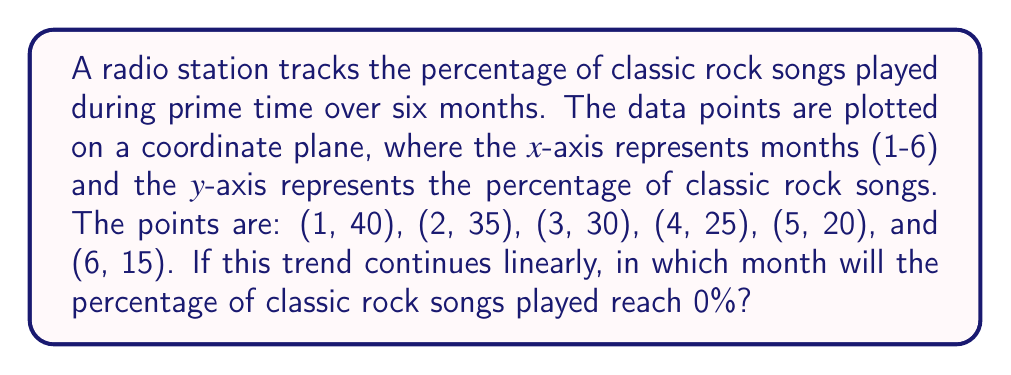Help me with this question. To solve this problem, we need to follow these steps:

1. Plot the given points on a coordinate plane.
2. Determine the slope of the line connecting these points.
3. Use the slope to find the equation of the line.
4. Solve the equation for y = 0 to find the x-value (month) when classic rock songs reach 0%.

Step 1: Plotting the points
We can visualize the points on a coordinate plane:

[asy]
size(200,200);
import graph;

xaxis("Months",0,8,Arrow);
yaxis("Percentage",0,50,Arrow);

for(int i=1; i<=6; ++i) {
  dot((i, 40-5*(i-1)));
}

draw((1,40)--(6,15),blue);
[/asy]

Step 2: Determining the slope
We can calculate the slope using any two points. Let's use (1, 40) and (6, 15):

$m = \frac{y_2 - y_1}{x_2 - x_1} = \frac{15 - 40}{6 - 1} = \frac{-25}{5} = -5$

The slope is -5, meaning the percentage decreases by 5% each month.

Step 3: Finding the equation of the line
Using the point-slope form of a line $(y - y_1 = m(x - x_1))$ and the point (1, 40):

$y - 40 = -5(x - 1)$
$y - 40 = -5x + 5$
$y = -5x + 45$

Step 4: Solving for y = 0
To find when the percentage reaches 0%, we set y to 0 and solve for x:

$0 = -5x + 45$
$5x = 45$
$x = 9$

Therefore, if the trend continues linearly, the percentage of classic rock songs will reach 0% in the 9th month.
Answer: 9th month 